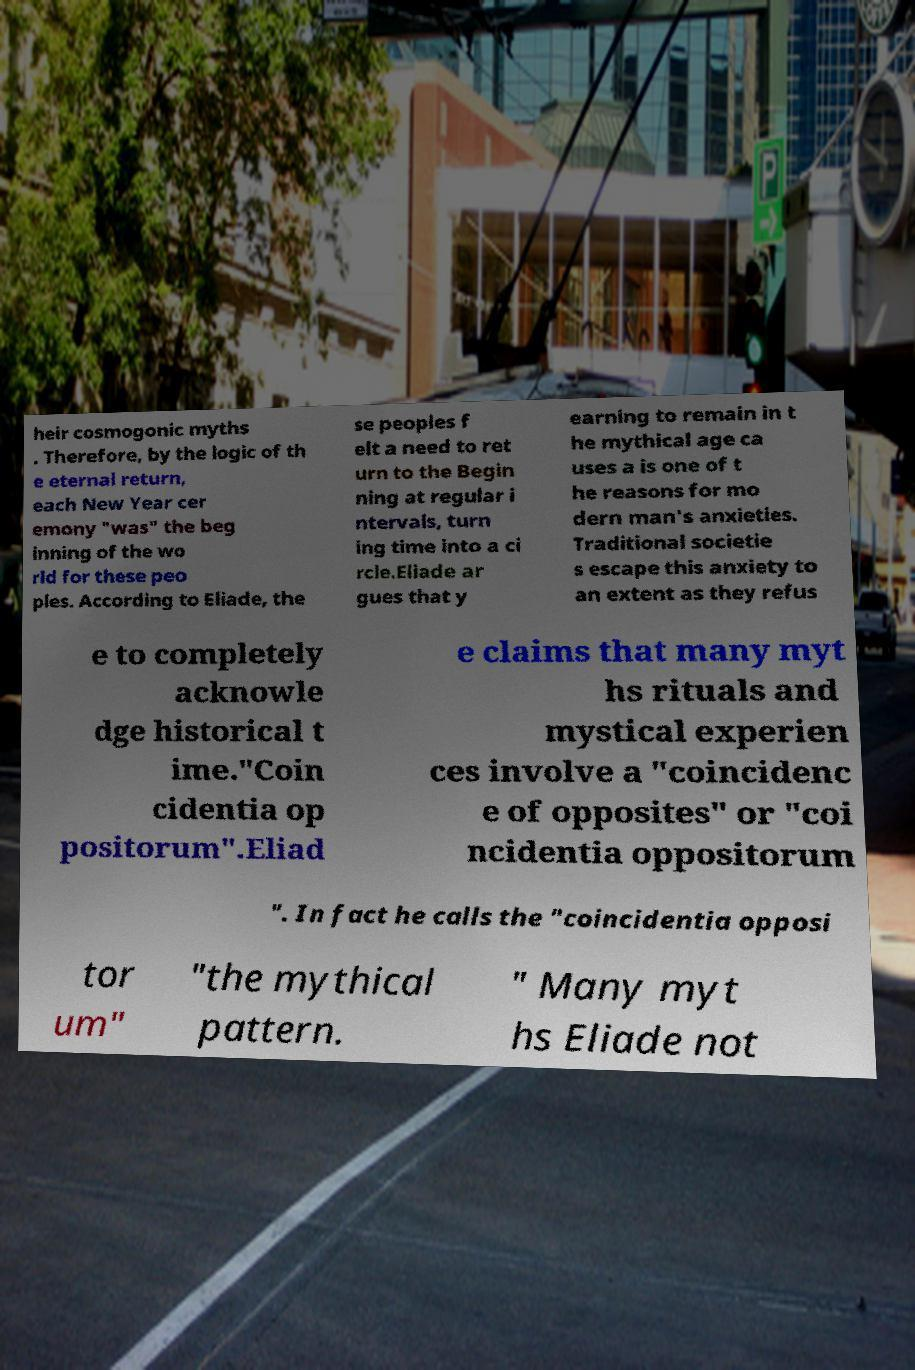There's text embedded in this image that I need extracted. Can you transcribe it verbatim? heir cosmogonic myths . Therefore, by the logic of th e eternal return, each New Year cer emony "was" the beg inning of the wo rld for these peo ples. According to Eliade, the se peoples f elt a need to ret urn to the Begin ning at regular i ntervals, turn ing time into a ci rcle.Eliade ar gues that y earning to remain in t he mythical age ca uses a is one of t he reasons for mo dern man's anxieties. Traditional societie s escape this anxiety to an extent as they refus e to completely acknowle dge historical t ime."Coin cidentia op positorum".Eliad e claims that many myt hs rituals and mystical experien ces involve a "coincidenc e of opposites" or "coi ncidentia oppositorum ". In fact he calls the "coincidentia opposi tor um" "the mythical pattern. " Many myt hs Eliade not 